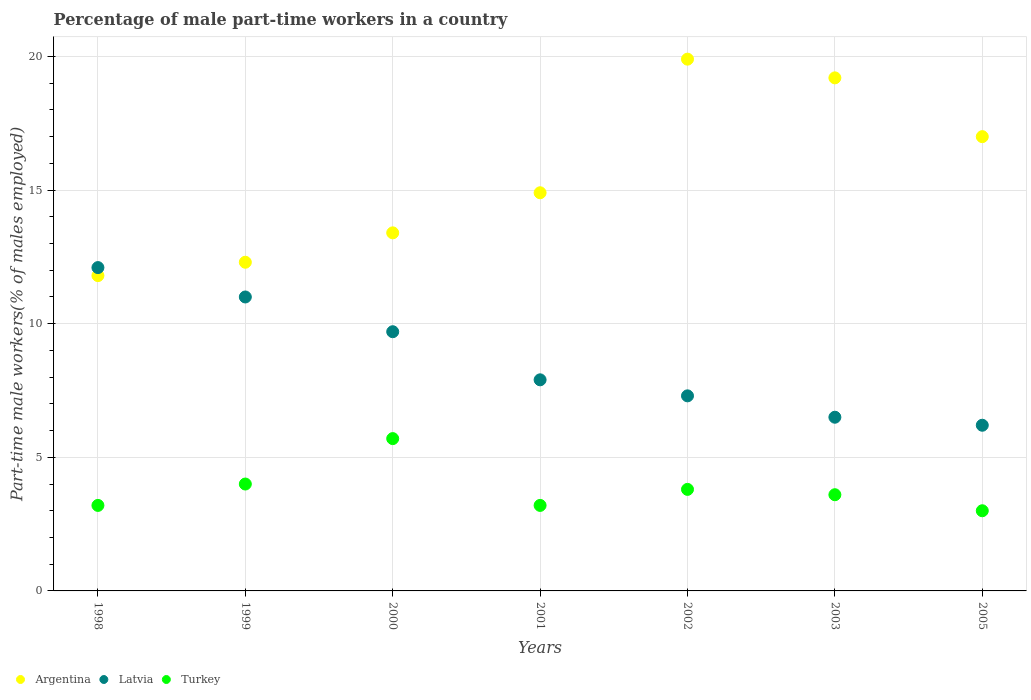How many different coloured dotlines are there?
Give a very brief answer. 3. Is the number of dotlines equal to the number of legend labels?
Offer a terse response. Yes. What is the percentage of male part-time workers in Latvia in 2000?
Ensure brevity in your answer.  9.7. Across all years, what is the maximum percentage of male part-time workers in Argentina?
Keep it short and to the point. 19.9. Across all years, what is the minimum percentage of male part-time workers in Turkey?
Give a very brief answer. 3. In which year was the percentage of male part-time workers in Turkey maximum?
Your answer should be very brief. 2000. What is the total percentage of male part-time workers in Turkey in the graph?
Your response must be concise. 26.5. What is the difference between the percentage of male part-time workers in Latvia in 1999 and that in 2002?
Provide a succinct answer. 3.7. What is the difference between the percentage of male part-time workers in Turkey in 2003 and the percentage of male part-time workers in Latvia in 2005?
Your response must be concise. -2.6. What is the average percentage of male part-time workers in Argentina per year?
Ensure brevity in your answer.  15.5. In the year 2005, what is the difference between the percentage of male part-time workers in Argentina and percentage of male part-time workers in Turkey?
Keep it short and to the point. 14. In how many years, is the percentage of male part-time workers in Latvia greater than 15 %?
Provide a succinct answer. 0. What is the ratio of the percentage of male part-time workers in Latvia in 1998 to that in 2005?
Give a very brief answer. 1.95. Is the difference between the percentage of male part-time workers in Argentina in 2001 and 2002 greater than the difference between the percentage of male part-time workers in Turkey in 2001 and 2002?
Your answer should be compact. No. What is the difference between the highest and the second highest percentage of male part-time workers in Turkey?
Make the answer very short. 1.7. What is the difference between the highest and the lowest percentage of male part-time workers in Latvia?
Ensure brevity in your answer.  5.9. Is it the case that in every year, the sum of the percentage of male part-time workers in Latvia and percentage of male part-time workers in Argentina  is greater than the percentage of male part-time workers in Turkey?
Offer a very short reply. Yes. Is the percentage of male part-time workers in Latvia strictly less than the percentage of male part-time workers in Turkey over the years?
Keep it short and to the point. No. How many dotlines are there?
Keep it short and to the point. 3. Are the values on the major ticks of Y-axis written in scientific E-notation?
Your answer should be compact. No. Does the graph contain any zero values?
Your answer should be very brief. No. Does the graph contain grids?
Give a very brief answer. Yes. Where does the legend appear in the graph?
Your response must be concise. Bottom left. How many legend labels are there?
Your answer should be compact. 3. How are the legend labels stacked?
Keep it short and to the point. Horizontal. What is the title of the graph?
Give a very brief answer. Percentage of male part-time workers in a country. Does "Australia" appear as one of the legend labels in the graph?
Make the answer very short. No. What is the label or title of the X-axis?
Give a very brief answer. Years. What is the label or title of the Y-axis?
Offer a terse response. Part-time male workers(% of males employed). What is the Part-time male workers(% of males employed) of Argentina in 1998?
Your response must be concise. 11.8. What is the Part-time male workers(% of males employed) in Latvia in 1998?
Offer a very short reply. 12.1. What is the Part-time male workers(% of males employed) in Turkey in 1998?
Give a very brief answer. 3.2. What is the Part-time male workers(% of males employed) in Argentina in 1999?
Offer a very short reply. 12.3. What is the Part-time male workers(% of males employed) in Argentina in 2000?
Offer a very short reply. 13.4. What is the Part-time male workers(% of males employed) in Latvia in 2000?
Make the answer very short. 9.7. What is the Part-time male workers(% of males employed) in Turkey in 2000?
Provide a succinct answer. 5.7. What is the Part-time male workers(% of males employed) in Argentina in 2001?
Provide a succinct answer. 14.9. What is the Part-time male workers(% of males employed) in Latvia in 2001?
Provide a succinct answer. 7.9. What is the Part-time male workers(% of males employed) of Turkey in 2001?
Make the answer very short. 3.2. What is the Part-time male workers(% of males employed) in Argentina in 2002?
Your response must be concise. 19.9. What is the Part-time male workers(% of males employed) in Latvia in 2002?
Provide a short and direct response. 7.3. What is the Part-time male workers(% of males employed) of Turkey in 2002?
Give a very brief answer. 3.8. What is the Part-time male workers(% of males employed) of Argentina in 2003?
Provide a short and direct response. 19.2. What is the Part-time male workers(% of males employed) of Latvia in 2003?
Provide a short and direct response. 6.5. What is the Part-time male workers(% of males employed) in Turkey in 2003?
Provide a short and direct response. 3.6. What is the Part-time male workers(% of males employed) of Argentina in 2005?
Your answer should be very brief. 17. What is the Part-time male workers(% of males employed) in Latvia in 2005?
Your answer should be compact. 6.2. Across all years, what is the maximum Part-time male workers(% of males employed) in Argentina?
Provide a succinct answer. 19.9. Across all years, what is the maximum Part-time male workers(% of males employed) of Latvia?
Provide a succinct answer. 12.1. Across all years, what is the maximum Part-time male workers(% of males employed) of Turkey?
Ensure brevity in your answer.  5.7. Across all years, what is the minimum Part-time male workers(% of males employed) in Argentina?
Your answer should be very brief. 11.8. Across all years, what is the minimum Part-time male workers(% of males employed) of Latvia?
Offer a terse response. 6.2. What is the total Part-time male workers(% of males employed) in Argentina in the graph?
Give a very brief answer. 108.5. What is the total Part-time male workers(% of males employed) of Latvia in the graph?
Offer a very short reply. 60.7. What is the total Part-time male workers(% of males employed) of Turkey in the graph?
Your response must be concise. 26.5. What is the difference between the Part-time male workers(% of males employed) of Latvia in 1998 and that in 1999?
Provide a succinct answer. 1.1. What is the difference between the Part-time male workers(% of males employed) in Turkey in 1998 and that in 1999?
Offer a very short reply. -0.8. What is the difference between the Part-time male workers(% of males employed) in Argentina in 1998 and that in 2001?
Ensure brevity in your answer.  -3.1. What is the difference between the Part-time male workers(% of males employed) in Turkey in 1998 and that in 2001?
Keep it short and to the point. 0. What is the difference between the Part-time male workers(% of males employed) in Argentina in 1998 and that in 2002?
Offer a terse response. -8.1. What is the difference between the Part-time male workers(% of males employed) of Latvia in 1998 and that in 2002?
Keep it short and to the point. 4.8. What is the difference between the Part-time male workers(% of males employed) in Turkey in 1998 and that in 2002?
Provide a short and direct response. -0.6. What is the difference between the Part-time male workers(% of males employed) in Turkey in 1998 and that in 2003?
Your response must be concise. -0.4. What is the difference between the Part-time male workers(% of males employed) in Argentina in 1999 and that in 2000?
Your response must be concise. -1.1. What is the difference between the Part-time male workers(% of males employed) of Turkey in 1999 and that in 2001?
Keep it short and to the point. 0.8. What is the difference between the Part-time male workers(% of males employed) of Latvia in 1999 and that in 2002?
Your answer should be very brief. 3.7. What is the difference between the Part-time male workers(% of males employed) in Argentina in 1999 and that in 2005?
Make the answer very short. -4.7. What is the difference between the Part-time male workers(% of males employed) in Turkey in 1999 and that in 2005?
Offer a very short reply. 1. What is the difference between the Part-time male workers(% of males employed) in Turkey in 2000 and that in 2001?
Ensure brevity in your answer.  2.5. What is the difference between the Part-time male workers(% of males employed) in Argentina in 2000 and that in 2002?
Ensure brevity in your answer.  -6.5. What is the difference between the Part-time male workers(% of males employed) of Latvia in 2000 and that in 2002?
Ensure brevity in your answer.  2.4. What is the difference between the Part-time male workers(% of males employed) of Turkey in 2000 and that in 2002?
Keep it short and to the point. 1.9. What is the difference between the Part-time male workers(% of males employed) of Latvia in 2000 and that in 2003?
Your answer should be compact. 3.2. What is the difference between the Part-time male workers(% of males employed) of Turkey in 2001 and that in 2002?
Make the answer very short. -0.6. What is the difference between the Part-time male workers(% of males employed) in Argentina in 2001 and that in 2003?
Give a very brief answer. -4.3. What is the difference between the Part-time male workers(% of males employed) of Turkey in 2001 and that in 2003?
Offer a terse response. -0.4. What is the difference between the Part-time male workers(% of males employed) of Latvia in 2001 and that in 2005?
Your answer should be very brief. 1.7. What is the difference between the Part-time male workers(% of males employed) in Argentina in 2002 and that in 2005?
Ensure brevity in your answer.  2.9. What is the difference between the Part-time male workers(% of males employed) in Latvia in 2002 and that in 2005?
Give a very brief answer. 1.1. What is the difference between the Part-time male workers(% of males employed) in Turkey in 2002 and that in 2005?
Your response must be concise. 0.8. What is the difference between the Part-time male workers(% of males employed) of Latvia in 2003 and that in 2005?
Your answer should be compact. 0.3. What is the difference between the Part-time male workers(% of males employed) in Argentina in 1998 and the Part-time male workers(% of males employed) in Latvia in 1999?
Offer a very short reply. 0.8. What is the difference between the Part-time male workers(% of males employed) in Argentina in 1998 and the Part-time male workers(% of males employed) in Latvia in 2000?
Your response must be concise. 2.1. What is the difference between the Part-time male workers(% of males employed) in Argentina in 1998 and the Part-time male workers(% of males employed) in Turkey in 2000?
Keep it short and to the point. 6.1. What is the difference between the Part-time male workers(% of males employed) of Latvia in 1998 and the Part-time male workers(% of males employed) of Turkey in 2000?
Provide a succinct answer. 6.4. What is the difference between the Part-time male workers(% of males employed) of Argentina in 1998 and the Part-time male workers(% of males employed) of Latvia in 2001?
Your answer should be very brief. 3.9. What is the difference between the Part-time male workers(% of males employed) in Latvia in 1998 and the Part-time male workers(% of males employed) in Turkey in 2001?
Offer a very short reply. 8.9. What is the difference between the Part-time male workers(% of males employed) of Latvia in 1998 and the Part-time male workers(% of males employed) of Turkey in 2002?
Give a very brief answer. 8.3. What is the difference between the Part-time male workers(% of males employed) in Latvia in 1998 and the Part-time male workers(% of males employed) in Turkey in 2003?
Your answer should be very brief. 8.5. What is the difference between the Part-time male workers(% of males employed) of Argentina in 1998 and the Part-time male workers(% of males employed) of Turkey in 2005?
Your response must be concise. 8.8. What is the difference between the Part-time male workers(% of males employed) in Argentina in 1999 and the Part-time male workers(% of males employed) in Latvia in 2000?
Offer a very short reply. 2.6. What is the difference between the Part-time male workers(% of males employed) in Argentina in 1999 and the Part-time male workers(% of males employed) in Turkey in 2000?
Give a very brief answer. 6.6. What is the difference between the Part-time male workers(% of males employed) of Latvia in 1999 and the Part-time male workers(% of males employed) of Turkey in 2000?
Your answer should be very brief. 5.3. What is the difference between the Part-time male workers(% of males employed) in Argentina in 1999 and the Part-time male workers(% of males employed) in Turkey in 2001?
Give a very brief answer. 9.1. What is the difference between the Part-time male workers(% of males employed) of Latvia in 1999 and the Part-time male workers(% of males employed) of Turkey in 2002?
Your answer should be compact. 7.2. What is the difference between the Part-time male workers(% of males employed) in Argentina in 1999 and the Part-time male workers(% of males employed) in Latvia in 2003?
Offer a very short reply. 5.8. What is the difference between the Part-time male workers(% of males employed) of Argentina in 1999 and the Part-time male workers(% of males employed) of Turkey in 2003?
Provide a short and direct response. 8.7. What is the difference between the Part-time male workers(% of males employed) of Argentina in 1999 and the Part-time male workers(% of males employed) of Latvia in 2005?
Ensure brevity in your answer.  6.1. What is the difference between the Part-time male workers(% of males employed) in Argentina in 1999 and the Part-time male workers(% of males employed) in Turkey in 2005?
Your answer should be very brief. 9.3. What is the difference between the Part-time male workers(% of males employed) in Argentina in 2000 and the Part-time male workers(% of males employed) in Latvia in 2001?
Offer a terse response. 5.5. What is the difference between the Part-time male workers(% of males employed) of Latvia in 2000 and the Part-time male workers(% of males employed) of Turkey in 2001?
Offer a terse response. 6.5. What is the difference between the Part-time male workers(% of males employed) of Argentina in 2000 and the Part-time male workers(% of males employed) of Turkey in 2002?
Provide a succinct answer. 9.6. What is the difference between the Part-time male workers(% of males employed) of Latvia in 2000 and the Part-time male workers(% of males employed) of Turkey in 2002?
Offer a terse response. 5.9. What is the difference between the Part-time male workers(% of males employed) in Argentina in 2000 and the Part-time male workers(% of males employed) in Latvia in 2003?
Provide a succinct answer. 6.9. What is the difference between the Part-time male workers(% of males employed) of Argentina in 2000 and the Part-time male workers(% of males employed) of Turkey in 2003?
Provide a short and direct response. 9.8. What is the difference between the Part-time male workers(% of males employed) of Argentina in 2001 and the Part-time male workers(% of males employed) of Latvia in 2002?
Keep it short and to the point. 7.6. What is the difference between the Part-time male workers(% of males employed) of Argentina in 2001 and the Part-time male workers(% of males employed) of Turkey in 2002?
Give a very brief answer. 11.1. What is the difference between the Part-time male workers(% of males employed) in Latvia in 2001 and the Part-time male workers(% of males employed) in Turkey in 2002?
Give a very brief answer. 4.1. What is the difference between the Part-time male workers(% of males employed) in Argentina in 2001 and the Part-time male workers(% of males employed) in Latvia in 2003?
Give a very brief answer. 8.4. What is the difference between the Part-time male workers(% of males employed) of Argentina in 2001 and the Part-time male workers(% of males employed) of Turkey in 2005?
Your answer should be very brief. 11.9. What is the difference between the Part-time male workers(% of males employed) of Latvia in 2001 and the Part-time male workers(% of males employed) of Turkey in 2005?
Make the answer very short. 4.9. What is the difference between the Part-time male workers(% of males employed) in Argentina in 2002 and the Part-time male workers(% of males employed) in Turkey in 2003?
Your answer should be compact. 16.3. What is the difference between the Part-time male workers(% of males employed) of Latvia in 2002 and the Part-time male workers(% of males employed) of Turkey in 2003?
Your answer should be very brief. 3.7. What is the difference between the Part-time male workers(% of males employed) of Latvia in 2002 and the Part-time male workers(% of males employed) of Turkey in 2005?
Ensure brevity in your answer.  4.3. What is the difference between the Part-time male workers(% of males employed) of Argentina in 2003 and the Part-time male workers(% of males employed) of Latvia in 2005?
Give a very brief answer. 13. What is the average Part-time male workers(% of males employed) in Argentina per year?
Provide a succinct answer. 15.5. What is the average Part-time male workers(% of males employed) of Latvia per year?
Give a very brief answer. 8.67. What is the average Part-time male workers(% of males employed) in Turkey per year?
Offer a very short reply. 3.79. In the year 1998, what is the difference between the Part-time male workers(% of males employed) of Argentina and Part-time male workers(% of males employed) of Latvia?
Make the answer very short. -0.3. In the year 1998, what is the difference between the Part-time male workers(% of males employed) of Argentina and Part-time male workers(% of males employed) of Turkey?
Ensure brevity in your answer.  8.6. In the year 1998, what is the difference between the Part-time male workers(% of males employed) of Latvia and Part-time male workers(% of males employed) of Turkey?
Your answer should be very brief. 8.9. In the year 1999, what is the difference between the Part-time male workers(% of males employed) in Argentina and Part-time male workers(% of males employed) in Turkey?
Your response must be concise. 8.3. In the year 1999, what is the difference between the Part-time male workers(% of males employed) of Latvia and Part-time male workers(% of males employed) of Turkey?
Provide a succinct answer. 7. In the year 2000, what is the difference between the Part-time male workers(% of males employed) of Argentina and Part-time male workers(% of males employed) of Turkey?
Provide a short and direct response. 7.7. In the year 2000, what is the difference between the Part-time male workers(% of males employed) of Latvia and Part-time male workers(% of males employed) of Turkey?
Your answer should be very brief. 4. In the year 2001, what is the difference between the Part-time male workers(% of males employed) of Argentina and Part-time male workers(% of males employed) of Latvia?
Provide a short and direct response. 7. In the year 2001, what is the difference between the Part-time male workers(% of males employed) in Latvia and Part-time male workers(% of males employed) in Turkey?
Ensure brevity in your answer.  4.7. In the year 2003, what is the difference between the Part-time male workers(% of males employed) in Argentina and Part-time male workers(% of males employed) in Latvia?
Keep it short and to the point. 12.7. In the year 2005, what is the difference between the Part-time male workers(% of males employed) in Argentina and Part-time male workers(% of males employed) in Latvia?
Provide a short and direct response. 10.8. What is the ratio of the Part-time male workers(% of males employed) of Argentina in 1998 to that in 1999?
Keep it short and to the point. 0.96. What is the ratio of the Part-time male workers(% of males employed) of Latvia in 1998 to that in 1999?
Provide a short and direct response. 1.1. What is the ratio of the Part-time male workers(% of males employed) of Argentina in 1998 to that in 2000?
Provide a succinct answer. 0.88. What is the ratio of the Part-time male workers(% of males employed) in Latvia in 1998 to that in 2000?
Your answer should be very brief. 1.25. What is the ratio of the Part-time male workers(% of males employed) of Turkey in 1998 to that in 2000?
Your answer should be compact. 0.56. What is the ratio of the Part-time male workers(% of males employed) in Argentina in 1998 to that in 2001?
Make the answer very short. 0.79. What is the ratio of the Part-time male workers(% of males employed) in Latvia in 1998 to that in 2001?
Keep it short and to the point. 1.53. What is the ratio of the Part-time male workers(% of males employed) of Turkey in 1998 to that in 2001?
Your answer should be very brief. 1. What is the ratio of the Part-time male workers(% of males employed) in Argentina in 1998 to that in 2002?
Your answer should be very brief. 0.59. What is the ratio of the Part-time male workers(% of males employed) in Latvia in 1998 to that in 2002?
Give a very brief answer. 1.66. What is the ratio of the Part-time male workers(% of males employed) of Turkey in 1998 to that in 2002?
Ensure brevity in your answer.  0.84. What is the ratio of the Part-time male workers(% of males employed) in Argentina in 1998 to that in 2003?
Your answer should be very brief. 0.61. What is the ratio of the Part-time male workers(% of males employed) in Latvia in 1998 to that in 2003?
Your response must be concise. 1.86. What is the ratio of the Part-time male workers(% of males employed) of Turkey in 1998 to that in 2003?
Provide a short and direct response. 0.89. What is the ratio of the Part-time male workers(% of males employed) of Argentina in 1998 to that in 2005?
Give a very brief answer. 0.69. What is the ratio of the Part-time male workers(% of males employed) in Latvia in 1998 to that in 2005?
Keep it short and to the point. 1.95. What is the ratio of the Part-time male workers(% of males employed) of Turkey in 1998 to that in 2005?
Give a very brief answer. 1.07. What is the ratio of the Part-time male workers(% of males employed) in Argentina in 1999 to that in 2000?
Offer a very short reply. 0.92. What is the ratio of the Part-time male workers(% of males employed) in Latvia in 1999 to that in 2000?
Your answer should be compact. 1.13. What is the ratio of the Part-time male workers(% of males employed) in Turkey in 1999 to that in 2000?
Your answer should be very brief. 0.7. What is the ratio of the Part-time male workers(% of males employed) of Argentina in 1999 to that in 2001?
Offer a very short reply. 0.83. What is the ratio of the Part-time male workers(% of males employed) in Latvia in 1999 to that in 2001?
Make the answer very short. 1.39. What is the ratio of the Part-time male workers(% of males employed) in Turkey in 1999 to that in 2001?
Your answer should be very brief. 1.25. What is the ratio of the Part-time male workers(% of males employed) in Argentina in 1999 to that in 2002?
Ensure brevity in your answer.  0.62. What is the ratio of the Part-time male workers(% of males employed) of Latvia in 1999 to that in 2002?
Ensure brevity in your answer.  1.51. What is the ratio of the Part-time male workers(% of males employed) of Turkey in 1999 to that in 2002?
Give a very brief answer. 1.05. What is the ratio of the Part-time male workers(% of males employed) in Argentina in 1999 to that in 2003?
Offer a terse response. 0.64. What is the ratio of the Part-time male workers(% of males employed) of Latvia in 1999 to that in 2003?
Keep it short and to the point. 1.69. What is the ratio of the Part-time male workers(% of males employed) of Argentina in 1999 to that in 2005?
Give a very brief answer. 0.72. What is the ratio of the Part-time male workers(% of males employed) of Latvia in 1999 to that in 2005?
Provide a short and direct response. 1.77. What is the ratio of the Part-time male workers(% of males employed) in Turkey in 1999 to that in 2005?
Your response must be concise. 1.33. What is the ratio of the Part-time male workers(% of males employed) in Argentina in 2000 to that in 2001?
Offer a terse response. 0.9. What is the ratio of the Part-time male workers(% of males employed) of Latvia in 2000 to that in 2001?
Offer a very short reply. 1.23. What is the ratio of the Part-time male workers(% of males employed) of Turkey in 2000 to that in 2001?
Offer a very short reply. 1.78. What is the ratio of the Part-time male workers(% of males employed) in Argentina in 2000 to that in 2002?
Your response must be concise. 0.67. What is the ratio of the Part-time male workers(% of males employed) of Latvia in 2000 to that in 2002?
Keep it short and to the point. 1.33. What is the ratio of the Part-time male workers(% of males employed) of Argentina in 2000 to that in 2003?
Offer a very short reply. 0.7. What is the ratio of the Part-time male workers(% of males employed) in Latvia in 2000 to that in 2003?
Your answer should be very brief. 1.49. What is the ratio of the Part-time male workers(% of males employed) of Turkey in 2000 to that in 2003?
Provide a short and direct response. 1.58. What is the ratio of the Part-time male workers(% of males employed) of Argentina in 2000 to that in 2005?
Your response must be concise. 0.79. What is the ratio of the Part-time male workers(% of males employed) of Latvia in 2000 to that in 2005?
Make the answer very short. 1.56. What is the ratio of the Part-time male workers(% of males employed) in Turkey in 2000 to that in 2005?
Provide a short and direct response. 1.9. What is the ratio of the Part-time male workers(% of males employed) in Argentina in 2001 to that in 2002?
Your answer should be compact. 0.75. What is the ratio of the Part-time male workers(% of males employed) in Latvia in 2001 to that in 2002?
Keep it short and to the point. 1.08. What is the ratio of the Part-time male workers(% of males employed) in Turkey in 2001 to that in 2002?
Give a very brief answer. 0.84. What is the ratio of the Part-time male workers(% of males employed) in Argentina in 2001 to that in 2003?
Provide a short and direct response. 0.78. What is the ratio of the Part-time male workers(% of males employed) in Latvia in 2001 to that in 2003?
Provide a succinct answer. 1.22. What is the ratio of the Part-time male workers(% of males employed) in Turkey in 2001 to that in 2003?
Your answer should be compact. 0.89. What is the ratio of the Part-time male workers(% of males employed) of Argentina in 2001 to that in 2005?
Your answer should be compact. 0.88. What is the ratio of the Part-time male workers(% of males employed) of Latvia in 2001 to that in 2005?
Provide a short and direct response. 1.27. What is the ratio of the Part-time male workers(% of males employed) of Turkey in 2001 to that in 2005?
Keep it short and to the point. 1.07. What is the ratio of the Part-time male workers(% of males employed) of Argentina in 2002 to that in 2003?
Make the answer very short. 1.04. What is the ratio of the Part-time male workers(% of males employed) in Latvia in 2002 to that in 2003?
Your answer should be compact. 1.12. What is the ratio of the Part-time male workers(% of males employed) in Turkey in 2002 to that in 2003?
Your response must be concise. 1.06. What is the ratio of the Part-time male workers(% of males employed) in Argentina in 2002 to that in 2005?
Ensure brevity in your answer.  1.17. What is the ratio of the Part-time male workers(% of males employed) of Latvia in 2002 to that in 2005?
Offer a very short reply. 1.18. What is the ratio of the Part-time male workers(% of males employed) in Turkey in 2002 to that in 2005?
Provide a short and direct response. 1.27. What is the ratio of the Part-time male workers(% of males employed) of Argentina in 2003 to that in 2005?
Your answer should be compact. 1.13. What is the ratio of the Part-time male workers(% of males employed) in Latvia in 2003 to that in 2005?
Your response must be concise. 1.05. What is the difference between the highest and the second highest Part-time male workers(% of males employed) in Turkey?
Keep it short and to the point. 1.7. What is the difference between the highest and the lowest Part-time male workers(% of males employed) of Turkey?
Keep it short and to the point. 2.7. 